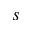<formula> <loc_0><loc_0><loc_500><loc_500>s</formula> 